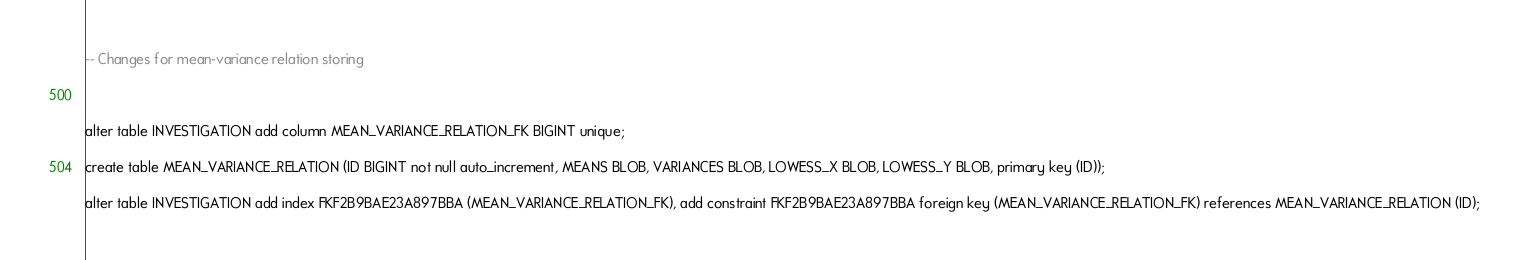Convert code to text. <code><loc_0><loc_0><loc_500><loc_500><_SQL_>-- Changes for mean-variance relation storing



alter table INVESTIGATION add column MEAN_VARIANCE_RELATION_FK BIGINT unique;

create table MEAN_VARIANCE_RELATION (ID BIGINT not null auto_increment, MEANS BLOB, VARIANCES BLOB, LOWESS_X BLOB, LOWESS_Y BLOB, primary key (ID));

alter table INVESTIGATION add index FKF2B9BAE23A897BBA (MEAN_VARIANCE_RELATION_FK), add constraint FKF2B9BAE23A897BBA foreign key (MEAN_VARIANCE_RELATION_FK) references MEAN_VARIANCE_RELATION (ID);
</code> 